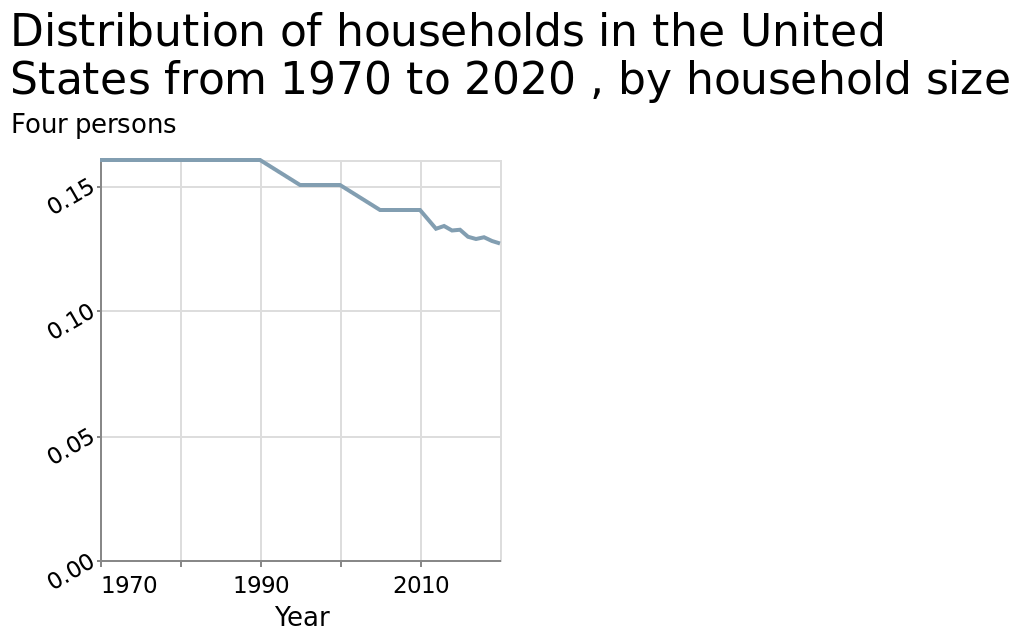<image>
Describe the following image in detail Here a is a line diagram titled Distribution of households in the United States from 1970 to 2020 , by household size. The y-axis plots Four persons using scale from 0.00 to 0.15 while the x-axis plots Year along linear scale of range 1970 to 2010. What is the title of the line diagram?  The line diagram is titled "Distribution of households in the United States from 1970 to 2020, by household size." What is the focus of the diagram? The diagram focuses on showing the distribution of households in the United States from 1970 to 2020, specifically by household size. Is there a pie chart titled Distribution of households in the United States from 1970 to 2020, by household size? No.Here a is a line diagram titled Distribution of households in the United States from 1970 to 2020 , by household size. The y-axis plots Four persons using scale from 0.00 to 0.15 while the x-axis plots Year along linear scale of range 1970 to 2010. 